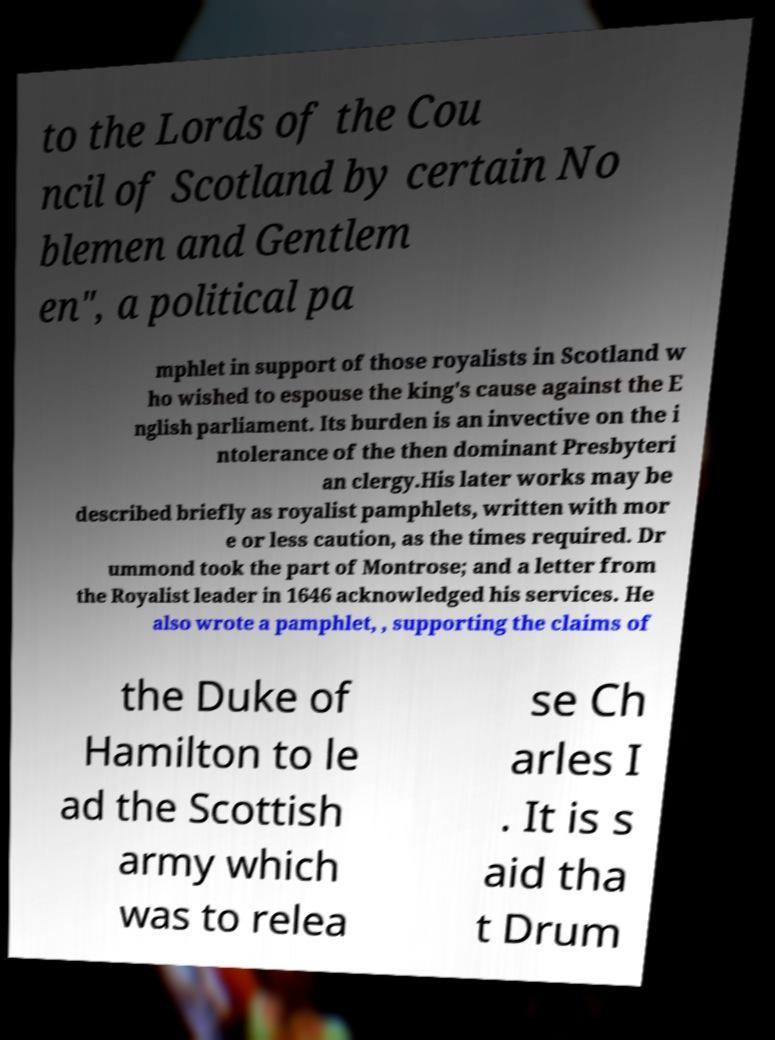Can you read and provide the text displayed in the image?This photo seems to have some interesting text. Can you extract and type it out for me? to the Lords of the Cou ncil of Scotland by certain No blemen and Gentlem en", a political pa mphlet in support of those royalists in Scotland w ho wished to espouse the king's cause against the E nglish parliament. Its burden is an invective on the i ntolerance of the then dominant Presbyteri an clergy.His later works may be described briefly as royalist pamphlets, written with mor e or less caution, as the times required. Dr ummond took the part of Montrose; and a letter from the Royalist leader in 1646 acknowledged his services. He also wrote a pamphlet, , supporting the claims of the Duke of Hamilton to le ad the Scottish army which was to relea se Ch arles I . It is s aid tha t Drum 